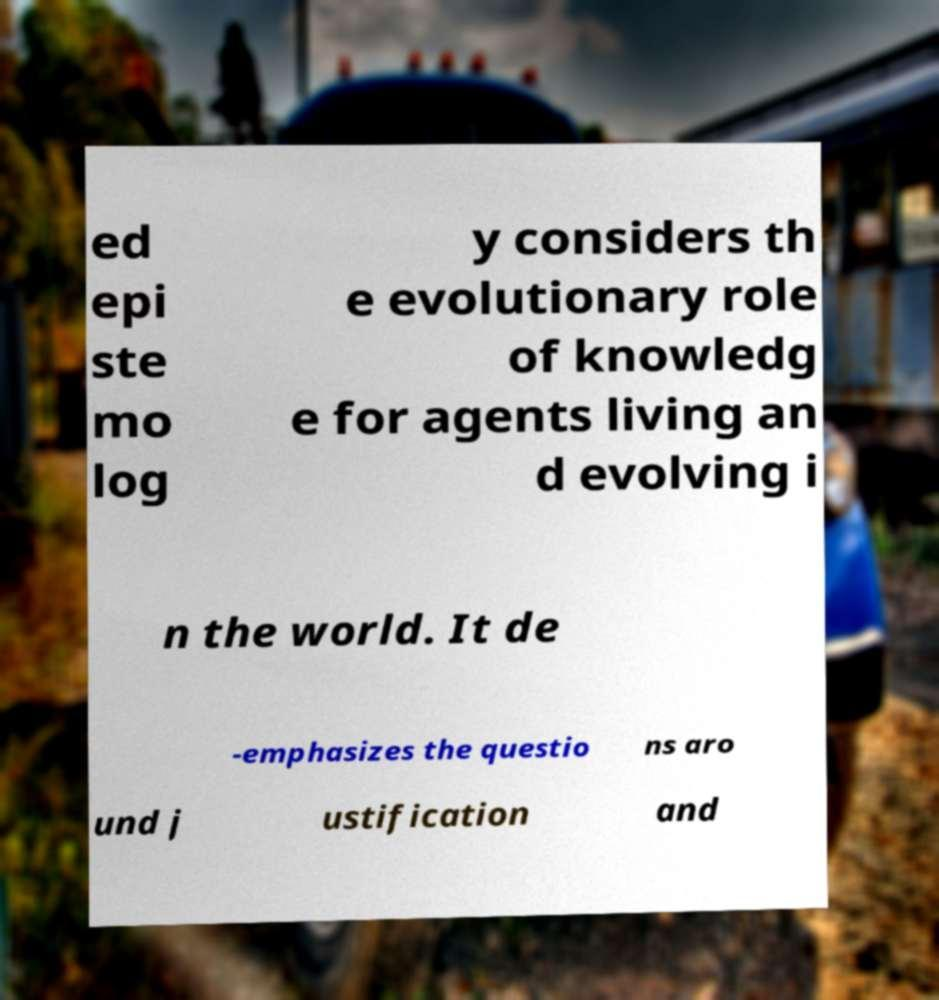I need the written content from this picture converted into text. Can you do that? ed epi ste mo log y considers th e evolutionary role of knowledg e for agents living an d evolving i n the world. It de -emphasizes the questio ns aro und j ustification and 